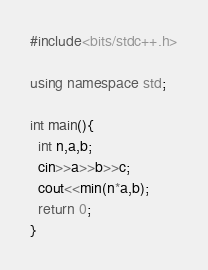Convert code to text. <code><loc_0><loc_0><loc_500><loc_500><_C++_>#include<bits/stdc++.h>

using namespace std;

int main(){
  int n,a,b;
  cin>>a>>b>>c;
  cout<<min(n*a,b);
  return 0;
}</code> 